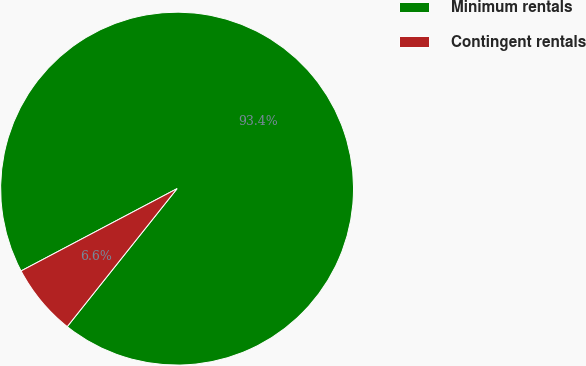<chart> <loc_0><loc_0><loc_500><loc_500><pie_chart><fcel>Minimum rentals<fcel>Contingent rentals<nl><fcel>93.43%<fcel>6.57%<nl></chart> 